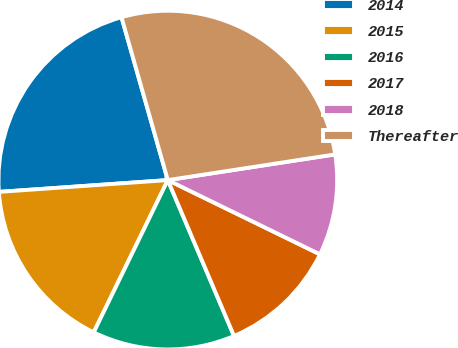Convert chart. <chart><loc_0><loc_0><loc_500><loc_500><pie_chart><fcel>2014<fcel>2015<fcel>2016<fcel>2017<fcel>2018<fcel>Thereafter<nl><fcel>21.7%<fcel>16.68%<fcel>13.6%<fcel>11.38%<fcel>9.65%<fcel>26.98%<nl></chart> 